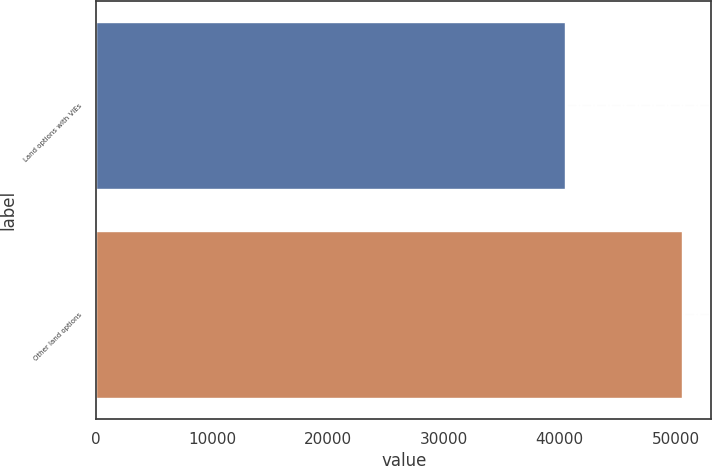Convert chart to OTSL. <chart><loc_0><loc_0><loc_500><loc_500><bar_chart><fcel>Land options with VIEs<fcel>Other land options<nl><fcel>40486<fcel>50548<nl></chart> 